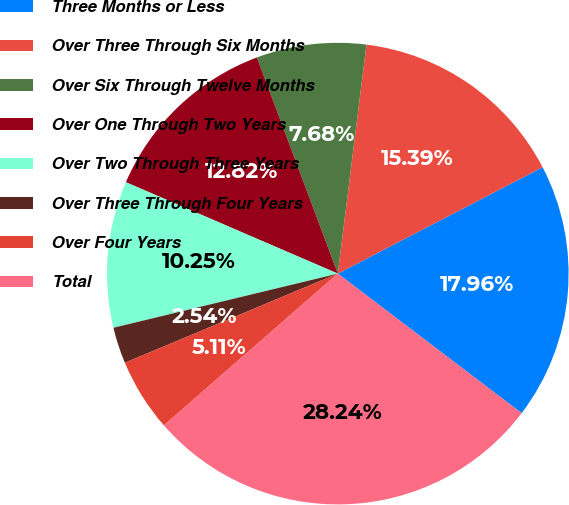<chart> <loc_0><loc_0><loc_500><loc_500><pie_chart><fcel>Three Months or Less<fcel>Over Three Through Six Months<fcel>Over Six Through Twelve Months<fcel>Over One Through Two Years<fcel>Over Two Through Three Years<fcel>Over Three Through Four Years<fcel>Over Four Years<fcel>Total<nl><fcel>17.96%<fcel>15.39%<fcel>7.68%<fcel>12.82%<fcel>10.25%<fcel>2.54%<fcel>5.11%<fcel>28.24%<nl></chart> 